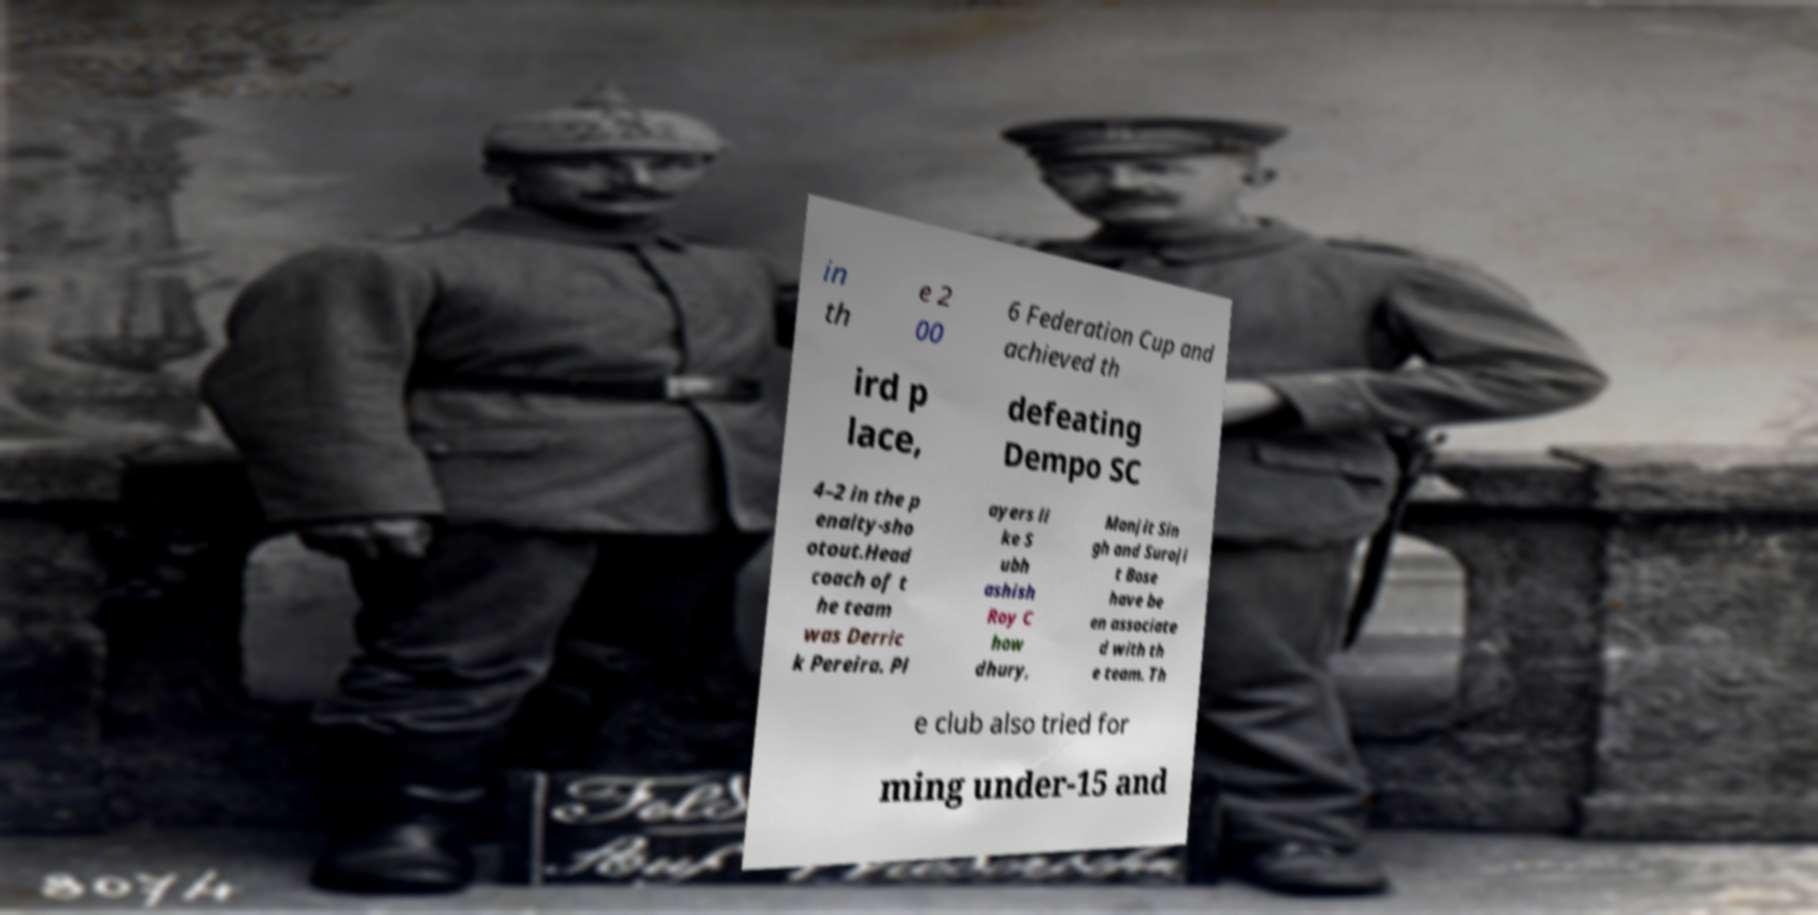Please identify and transcribe the text found in this image. in th e 2 00 6 Federation Cup and achieved th ird p lace, defeating Dempo SC 4–2 in the p enalty-sho otout.Head coach of t he team was Derric k Pereira. Pl ayers li ke S ubh ashish Roy C how dhury, Manjit Sin gh and Suroji t Bose have be en associate d with th e team. Th e club also tried for ming under-15 and 